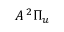Convert formula to latex. <formula><loc_0><loc_0><loc_500><loc_500>A \, { ^ { 2 } \Pi _ { u } }</formula> 